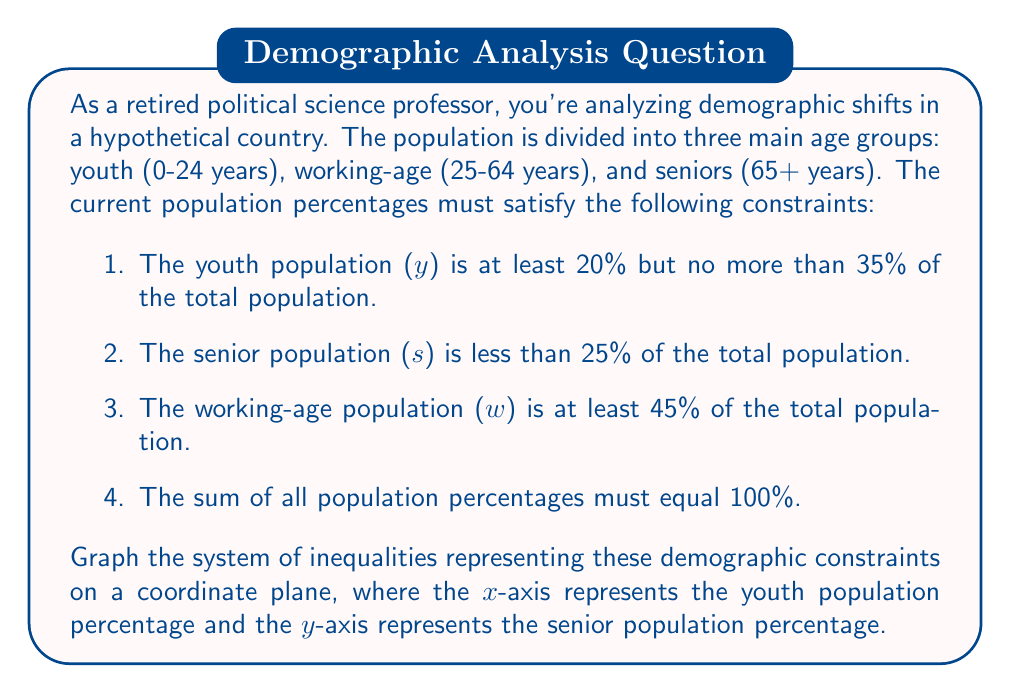Can you answer this question? Let's approach this step-by-step:

1) First, let's express our constraints mathematically:

   a) $20 \leq y \leq 35$
   b) $s < 25$
   c) $w \geq 45$
   d) $y + s + w = 100$

2) We need to express all constraints in terms of y and s, as these will be our x and y axes respectively.

3) From constraint (d), we can derive: $w = 100 - y - s$

4) Substituting this into constraint (c):
   $100 - y - s \geq 45$
   $-y - s \geq -55$
   $y + s \leq 55$

5) Now we have all our constraints in terms of y and s:

   $20 \leq y \leq 35$
   $s < 25$
   $y + s \leq 55$

6) Let's graph each inequality:

   - $y \geq 20$ is a vertical line at x = 20
   - $y \leq 35$ is a vertical line at x = 35
   - $s < 25$ is a horizontal line at y = 25
   - $y + s \leq 55$ is a line from (0, 55) to (55, 0)

7) The feasible region is the area that satisfies all these inequalities simultaneously.

[asy]
size(200,200);
import graph;

// Draw axes
draw((-5,0)--(60,0),arrow=Arrow(TeXHead));
draw((0,-5)--(0,60),arrow=Arrow(TeXHead));

// Label axes
label("Youth %", (60,0), E);
label("Senior %", (0,60), N);

// Draw constraints
draw((20,0)--(20,60),blue);
draw((35,0)--(35,60),blue);
draw((0,25)--(60,25),red);
draw((0,55)--(55,0),green);

// Shade feasible region
fill((20,0)--(35,0)--(35,20)--(20,25)--(20,0),gray(0.7));

// Label constraints
label("y = 20", (20,50), W, blue);
label("y = 35", (35,50), E, blue);
label("s = 25", (50,25), E, red);
label("y + s = 55", (40,15), SE, green);

// Label points
label("(20, 25)", (20,25), NW);
label("(35, 20)", (35,20), SE);
[/asy]

The shaded region represents all possible combinations of youth and senior population percentages that satisfy all the given constraints.
Answer: The system of inequalities is graphed as shown in the figure. The feasible region (shaded area) is bounded by the lines $y = 20$, $y = 35$, $s = 25$, and $y + s = 55$, representing all possible combinations of youth and senior population percentages that satisfy the given demographic constraints. 